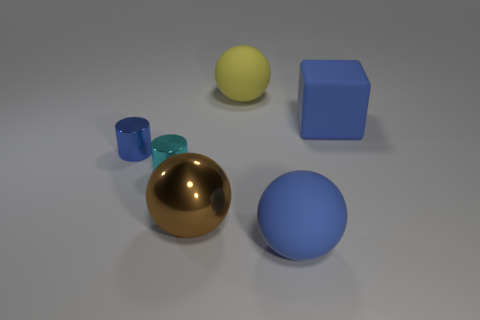What number of big metallic objects have the same color as the big metal ball? There are no other big metallic objects that have the same color as the big gold metal ball in the image. 